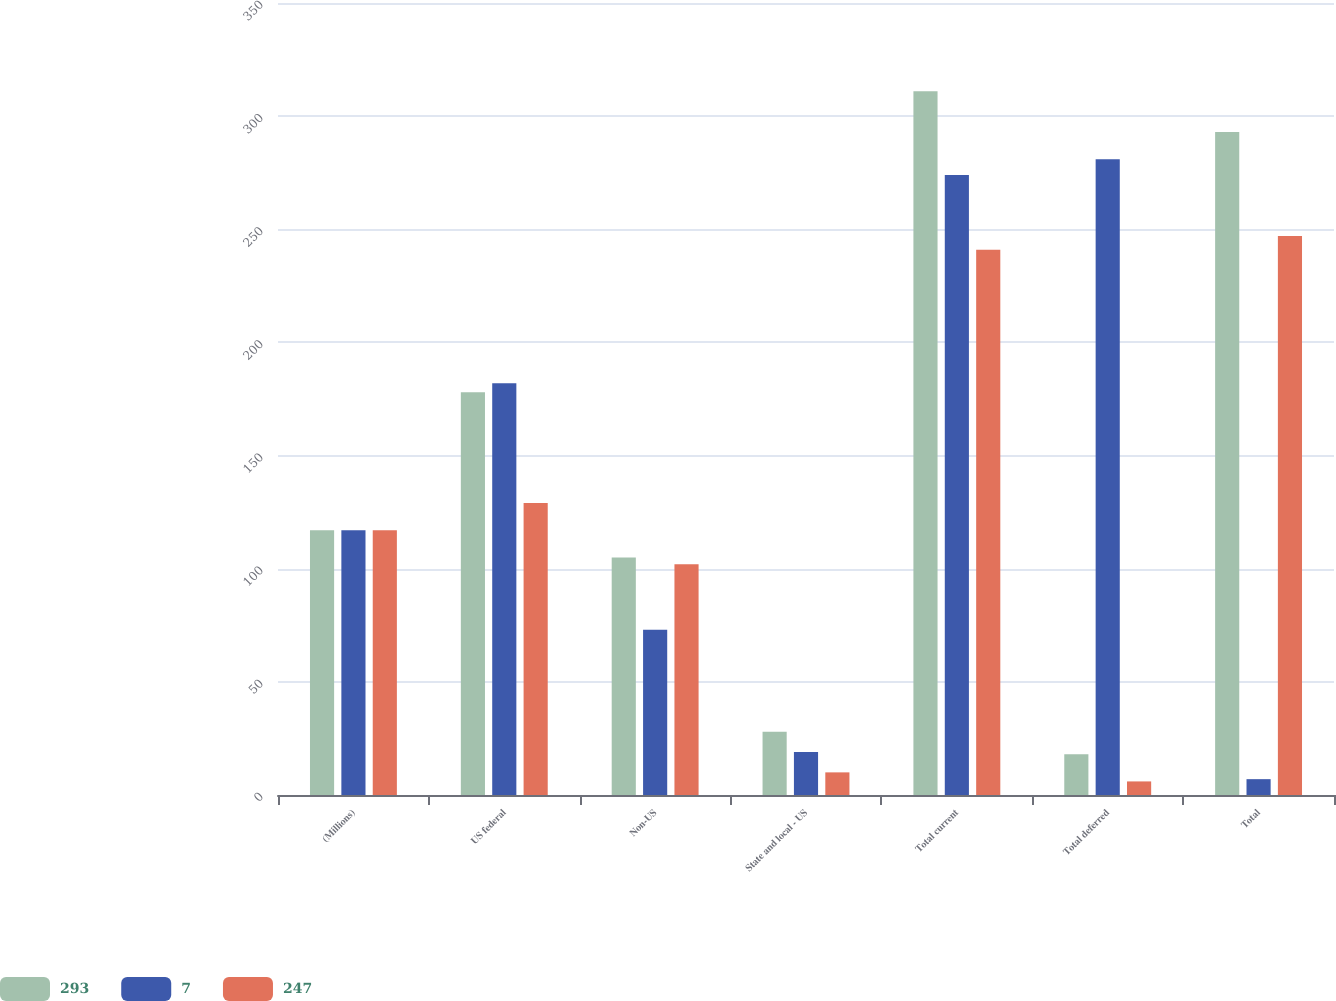Convert chart to OTSL. <chart><loc_0><loc_0><loc_500><loc_500><stacked_bar_chart><ecel><fcel>(Millions)<fcel>US federal<fcel>Non-US<fcel>State and local - US<fcel>Total current<fcel>Total deferred<fcel>Total<nl><fcel>293<fcel>117<fcel>178<fcel>105<fcel>28<fcel>311<fcel>18<fcel>293<nl><fcel>7<fcel>117<fcel>182<fcel>73<fcel>19<fcel>274<fcel>281<fcel>7<nl><fcel>247<fcel>117<fcel>129<fcel>102<fcel>10<fcel>241<fcel>6<fcel>247<nl></chart> 